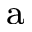<formula> <loc_0><loc_0><loc_500><loc_500>^ { a }</formula> 